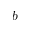Convert formula to latex. <formula><loc_0><loc_0><loc_500><loc_500>b</formula> 